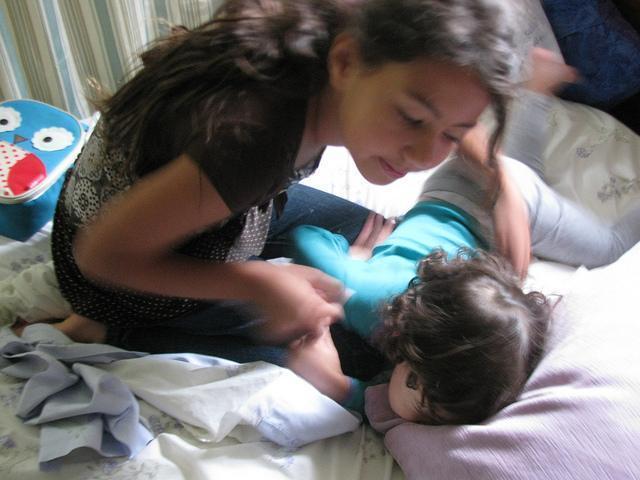How many beds can be seen?
Give a very brief answer. 1. How many people are in the picture?
Give a very brief answer. 2. 